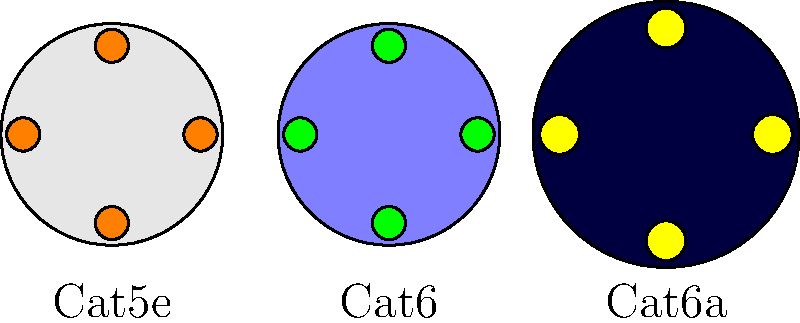As a network engineer focused on cost-efficiency, which of the depicted Ethernet cable types would you recommend for a new office setup that requires reliable Gigabit Ethernet performance but doesn't need 10 Gigabit speeds? To answer this question, let's analyze each cable type shown in the diagram:

1. Cat5e (leftmost):
   - Recognizable by its light gray outer sheath and orange conductors
   - Supports Gigabit Ethernet (1000BASE-T) up to 100 meters
   - Most cost-effective option for Gigabit networks

2. Cat6 (middle):
   - Light blue outer sheath with green conductors
   - Supports Gigabit Ethernet and can handle 10 Gigabit Ethernet for shorter distances
   - More expensive than Cat5e but offers better performance and future-proofing

3. Cat6a (rightmost):
   - Dark blue outer sheath with yellow conductors
   - Larger overall diameter, indicating additional shielding
   - Supports 10 Gigabit Ethernet up to 100 meters
   - Most expensive option among the three

Considering the requirement for reliable Gigabit Ethernet performance without the need for 10 Gigabit speeds, the most cost-effective solution would be Cat5e. It meets the performance requirements while being the least expensive option, aligning with the goal of maximizing financial efficiency.

Cat6 and Cat6a would be overkill for this scenario, as they offer capabilities beyond what is required and come at a higher cost.
Answer: Cat5e 